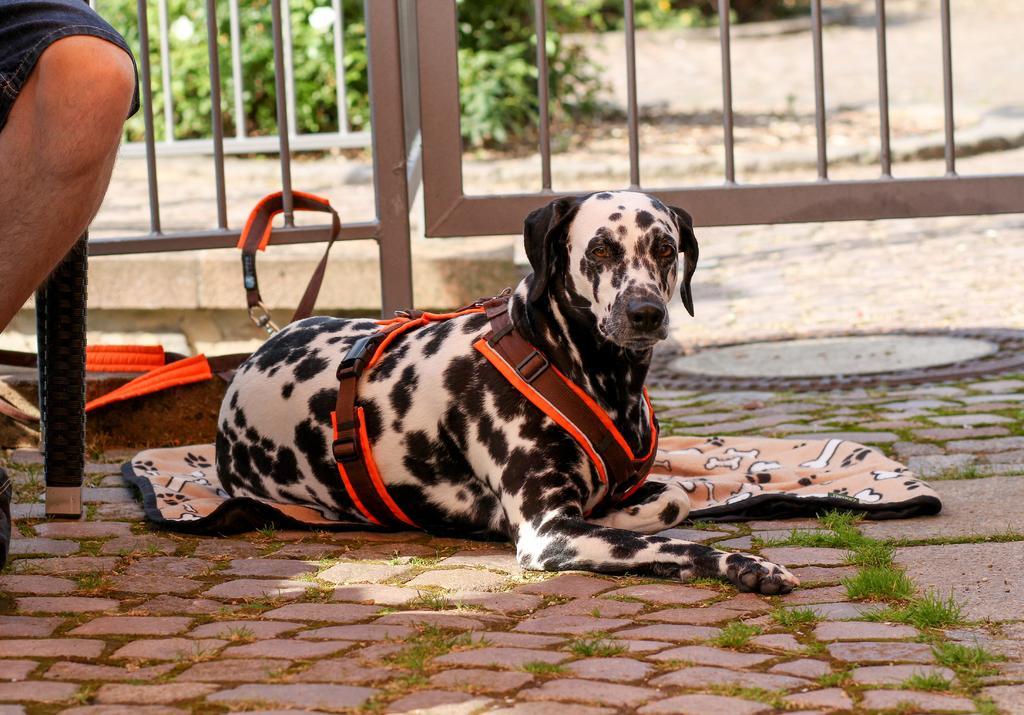Can you describe this image briefly? In this image we can see a dog, there are some plants, grass, fence and a cloth, also we can see a person truncated. 